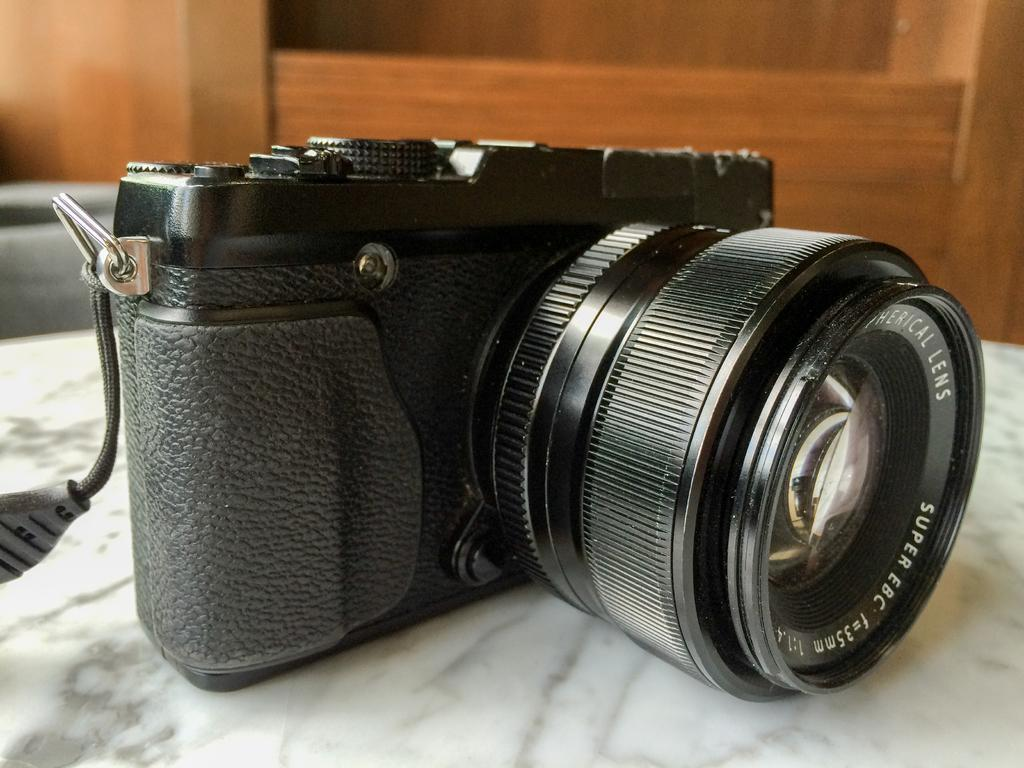What is the main subject of the image? The main subject of the image is a camera. What is the color of the surface on which the camera is placed? The camera is on a white surface. What type of object can be seen behind the camera? There is a wooden object behind the camera. What type of yarn is being distributed in the sky in the image? There is no yarn or distribution of yarn in the sky in the image. 